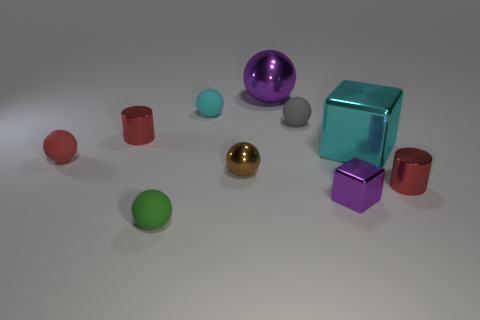Are there an equal number of green rubber spheres that are right of the tiny brown shiny thing and blocks that are on the left side of the big cyan cube?
Ensure brevity in your answer.  No. There is a small cyan object behind the large cyan shiny thing; what material is it?
Offer a terse response. Rubber. Is the number of gray objects less than the number of large things?
Provide a short and direct response. Yes. The metallic object that is both behind the brown thing and on the right side of the gray object has what shape?
Make the answer very short. Cube. How many green balls are there?
Your answer should be compact. 1. The red cylinder behind the red shiny cylinder that is right of the big cyan metallic object that is on the right side of the large purple shiny ball is made of what material?
Provide a short and direct response. Metal. How many tiny red spheres are behind the red metallic thing that is left of the green sphere?
Provide a short and direct response. 0. There is a small object that is the same shape as the large cyan metallic object; what is its color?
Ensure brevity in your answer.  Purple. Does the small purple cube have the same material as the red sphere?
Ensure brevity in your answer.  No. How many cylinders are gray objects or purple metallic objects?
Your answer should be compact. 0. 